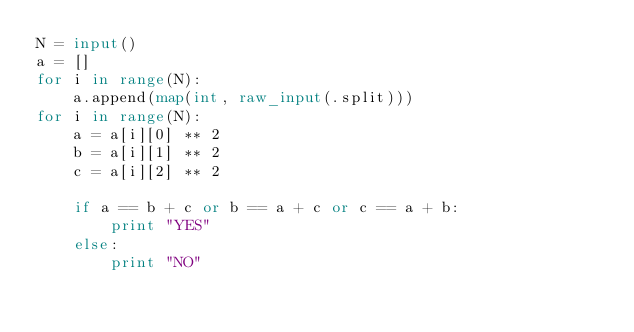<code> <loc_0><loc_0><loc_500><loc_500><_Python_>N = input()
a = []
for i in range(N):
    a.append(map(int, raw_input(.split)))
for i in range(N):
    a = a[i][0] ** 2
    b = a[i][1] ** 2
    c = a[i][2] ** 2

    if a == b + c or b == a + c or c == a + b:
        print "YES"
    else:
        print "NO"</code> 